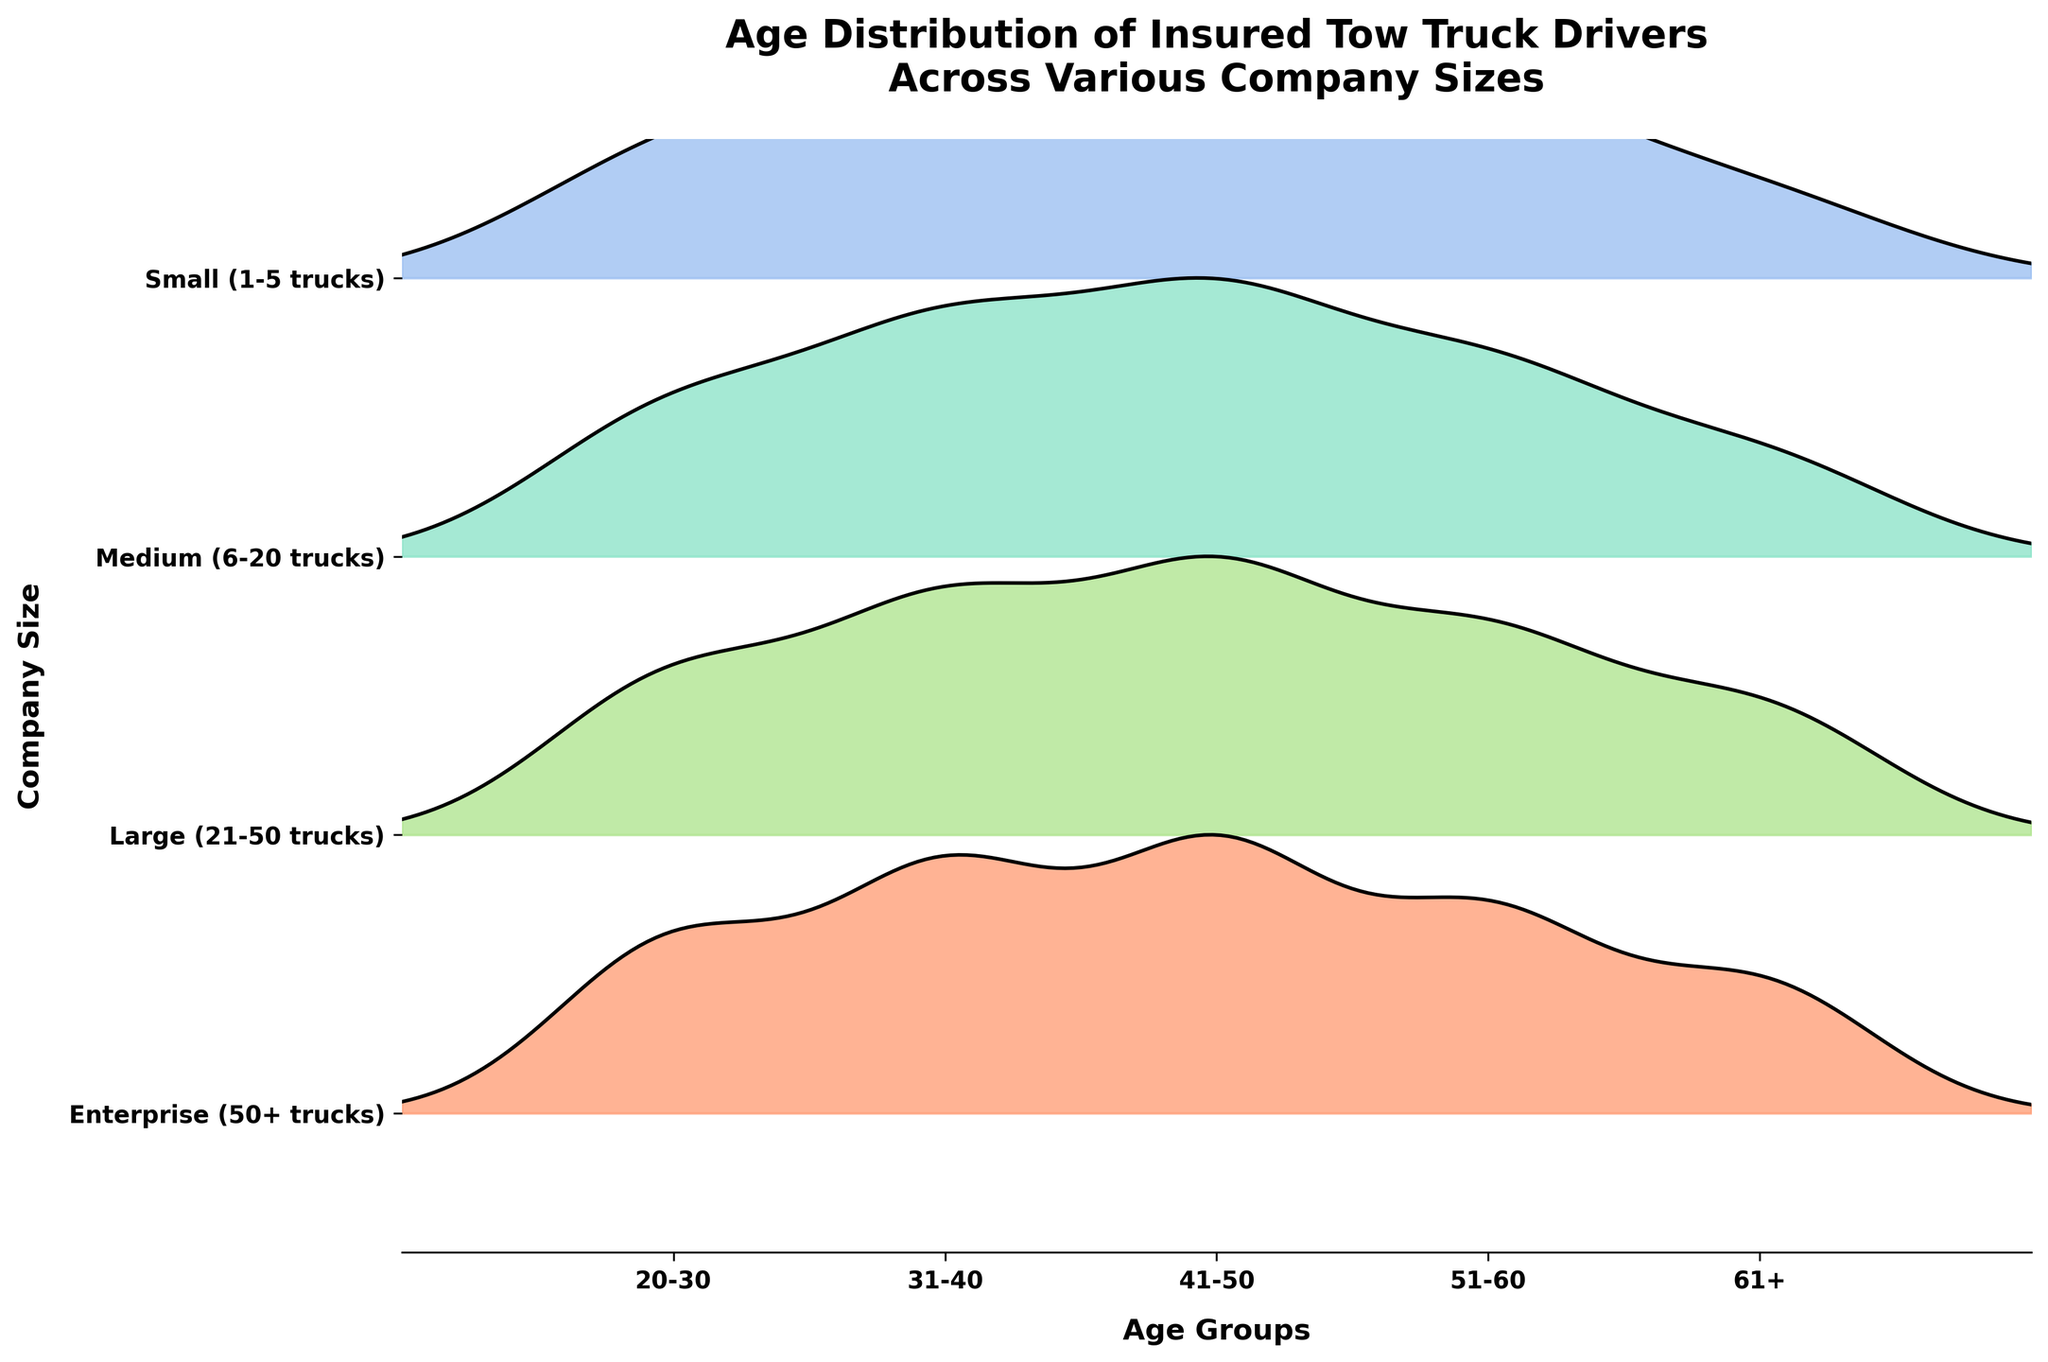What is the title of the plot? The title is located at the top of the plot and provides an overview of what the plot represents.
Answer: Age Distribution of Insured Tow Truck Drivers Across Various Company Sizes Which age group has the highest frequency of insured drivers in enterprise companies? Look at the plot's enterprise section and identify the age group with the highest peak.
Answer: 41-50 How many age groups are represented in the plot? The x-axis shows the different age groups. Count the number of distinct age groups listed.
Answer: 5 Which company size shows the widest range in driver age distribution? Observe the spread of the density ridgelines for each company size. The company size with consistently high peaks across different age groups has the widest range.
Answer: Enterprise Compare the age distribution peaks of medium and large companies; which age group has the higher peak in each? Look at the ridgelines for medium and large companies. Compare the height of peaks for each age group in both the sections.
Answer: Medium: 41-50, Large: 41-50 Does any company size have a peak frequency for drivers aged 61+ higher than 20? Inspect the height of the ridgelines for the 61+ age group in each company size.
Answer: Yes, Enterprise What is the most frequent age group for small-sized companies? Refer to the highest peak within the ridgeline of the small company size section.
Answer: 41-50 Are there any age groups where all company sizes show similar frequencies? Look at the ridgelines and check if any age group's peaks are closely aligned across all company sizes.
Answer: No Which age group has the smallest frequency in medium companies? Within the medium company size section, find the age group with the lowest peak.
Answer: 61+ For companies with 6-20 trucks, whose age distribution falls within what range? Check the start and end points of the ridgeline for medium companies on the x-axis.
Answer: 20-61+ 